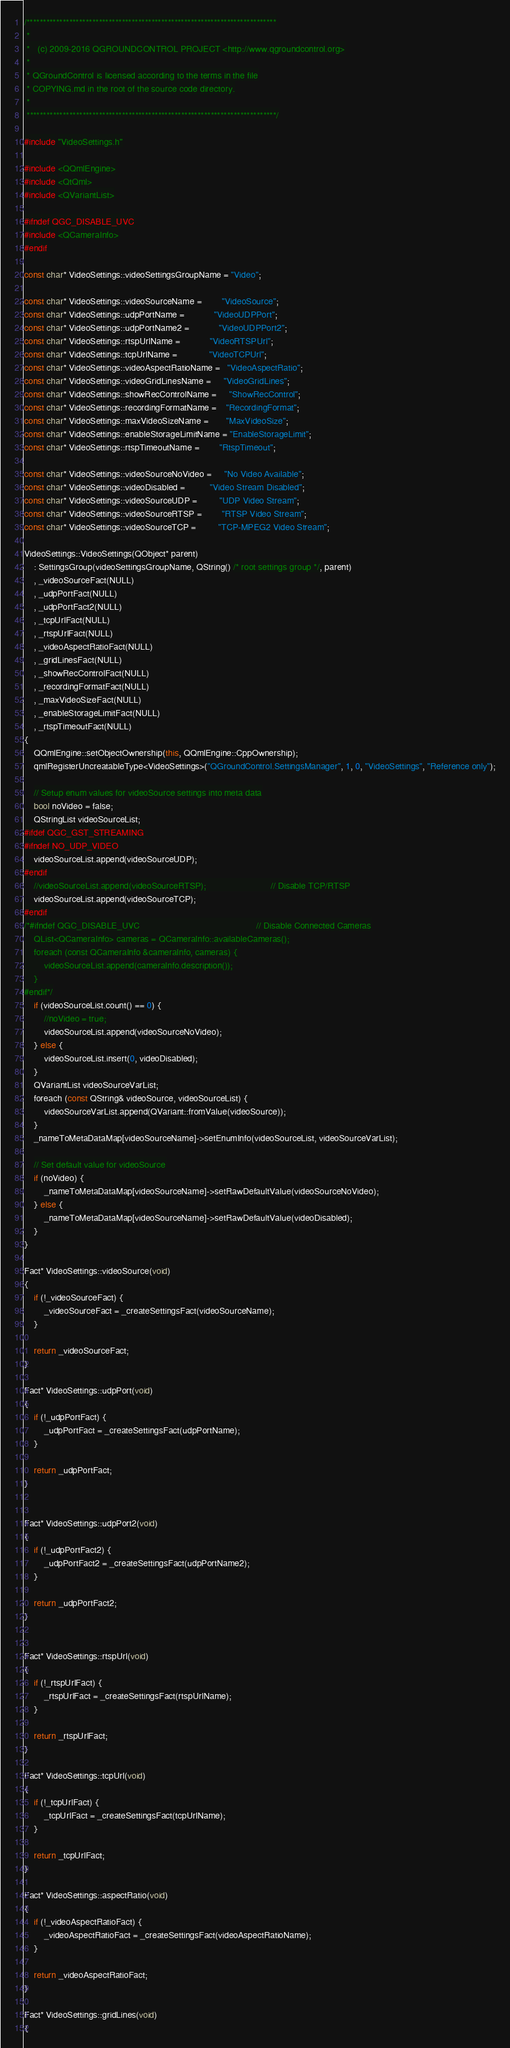Convert code to text. <code><loc_0><loc_0><loc_500><loc_500><_C++_>/****************************************************************************
 *
 *   (c) 2009-2016 QGROUNDCONTROL PROJECT <http://www.qgroundcontrol.org>
 *
 * QGroundControl is licensed according to the terms in the file
 * COPYING.md in the root of the source code directory.
 *
 ****************************************************************************/

#include "VideoSettings.h"

#include <QQmlEngine>
#include <QtQml>
#include <QVariantList>

#ifndef QGC_DISABLE_UVC
#include <QCameraInfo>
#endif

const char* VideoSettings::videoSettingsGroupName = "Video";

const char* VideoSettings::videoSourceName =        "VideoSource";
const char* VideoSettings::udpPortName =            "VideoUDPPort";
const char* VideoSettings::udpPortName2 =            "VideoUDPPort2";
const char* VideoSettings::rtspUrlName =            "VideoRTSPUrl";
const char* VideoSettings::tcpUrlName =             "VideoTCPUrl";
const char* VideoSettings::videoAspectRatioName =   "VideoAspectRatio";
const char* VideoSettings::videoGridLinesName =     "VideoGridLines";
const char* VideoSettings::showRecControlName =     "ShowRecControl";
const char* VideoSettings::recordingFormatName =    "RecordingFormat";
const char* VideoSettings::maxVideoSizeName =       "MaxVideoSize";
const char* VideoSettings::enableStorageLimitName = "EnableStorageLimit";
const char* VideoSettings::rtspTimeoutName =        "RtspTimeout";

const char* VideoSettings::videoSourceNoVideo =     "No Video Available";
const char* VideoSettings::videoDisabled =          "Video Stream Disabled";
const char* VideoSettings::videoSourceUDP =         "UDP Video Stream";
const char* VideoSettings::videoSourceRTSP =        "RTSP Video Stream";
const char* VideoSettings::videoSourceTCP =         "TCP-MPEG2 Video Stream";

VideoSettings::VideoSettings(QObject* parent)
    : SettingsGroup(videoSettingsGroupName, QString() /* root settings group */, parent)
    , _videoSourceFact(NULL)
    , _udpPortFact(NULL)
    , _udpPortFact2(NULL)
    , _tcpUrlFact(NULL)
    , _rtspUrlFact(NULL)
    , _videoAspectRatioFact(NULL)
    , _gridLinesFact(NULL)
    , _showRecControlFact(NULL)
    , _recordingFormatFact(NULL)
    , _maxVideoSizeFact(NULL)
    , _enableStorageLimitFact(NULL)
    , _rtspTimeoutFact(NULL)
{
    QQmlEngine::setObjectOwnership(this, QQmlEngine::CppOwnership);
    qmlRegisterUncreatableType<VideoSettings>("QGroundControl.SettingsManager", 1, 0, "VideoSettings", "Reference only");

    // Setup enum values for videoSource settings into meta data
    bool noVideo = false;
    QStringList videoSourceList;
#ifdef QGC_GST_STREAMING
#ifndef NO_UDP_VIDEO
    videoSourceList.append(videoSourceUDP);
#endif
    //videoSourceList.append(videoSourceRTSP);                          // Disable TCP/RTSP
    videoSourceList.append(videoSourceTCP);
#endif
/*#ifndef QGC_DISABLE_UVC                                               // Disable Connected Cameras
    QList<QCameraInfo> cameras = QCameraInfo::availableCameras();
    foreach (const QCameraInfo &cameraInfo, cameras) {
        videoSourceList.append(cameraInfo.description());
    }
#endif*/
    if (videoSourceList.count() == 0) {
        //noVideo = true;
        videoSourceList.append(videoSourceNoVideo);
    } else {
        videoSourceList.insert(0, videoDisabled);
    }
    QVariantList videoSourceVarList;
    foreach (const QString& videoSource, videoSourceList) {
        videoSourceVarList.append(QVariant::fromValue(videoSource));
    }
    _nameToMetaDataMap[videoSourceName]->setEnumInfo(videoSourceList, videoSourceVarList);

    // Set default value for videoSource
    if (noVideo) {
        _nameToMetaDataMap[videoSourceName]->setRawDefaultValue(videoSourceNoVideo);
    } else {
        _nameToMetaDataMap[videoSourceName]->setRawDefaultValue(videoDisabled);
    }
}

Fact* VideoSettings::videoSource(void)
{
    if (!_videoSourceFact) {
        _videoSourceFact = _createSettingsFact(videoSourceName);
    }

    return _videoSourceFact;
}

Fact* VideoSettings::udpPort(void)
{
    if (!_udpPortFact) {
        _udpPortFact = _createSettingsFact(udpPortName);
    }

    return _udpPortFact;
}


Fact* VideoSettings::udpPort2(void)
{
    if (!_udpPortFact2) {
        _udpPortFact2 = _createSettingsFact(udpPortName2);
    }

    return _udpPortFact2;
}


Fact* VideoSettings::rtspUrl(void)
{
    if (!_rtspUrlFact) {
        _rtspUrlFact = _createSettingsFact(rtspUrlName);
    }

    return _rtspUrlFact;
}

Fact* VideoSettings::tcpUrl(void)
{
    if (!_tcpUrlFact) {
        _tcpUrlFact = _createSettingsFact(tcpUrlName);
    }

    return _tcpUrlFact;
}

Fact* VideoSettings::aspectRatio(void)
{
    if (!_videoAspectRatioFact) {
        _videoAspectRatioFact = _createSettingsFact(videoAspectRatioName);
    }

    return _videoAspectRatioFact;
}

Fact* VideoSettings::gridLines(void)
{</code> 